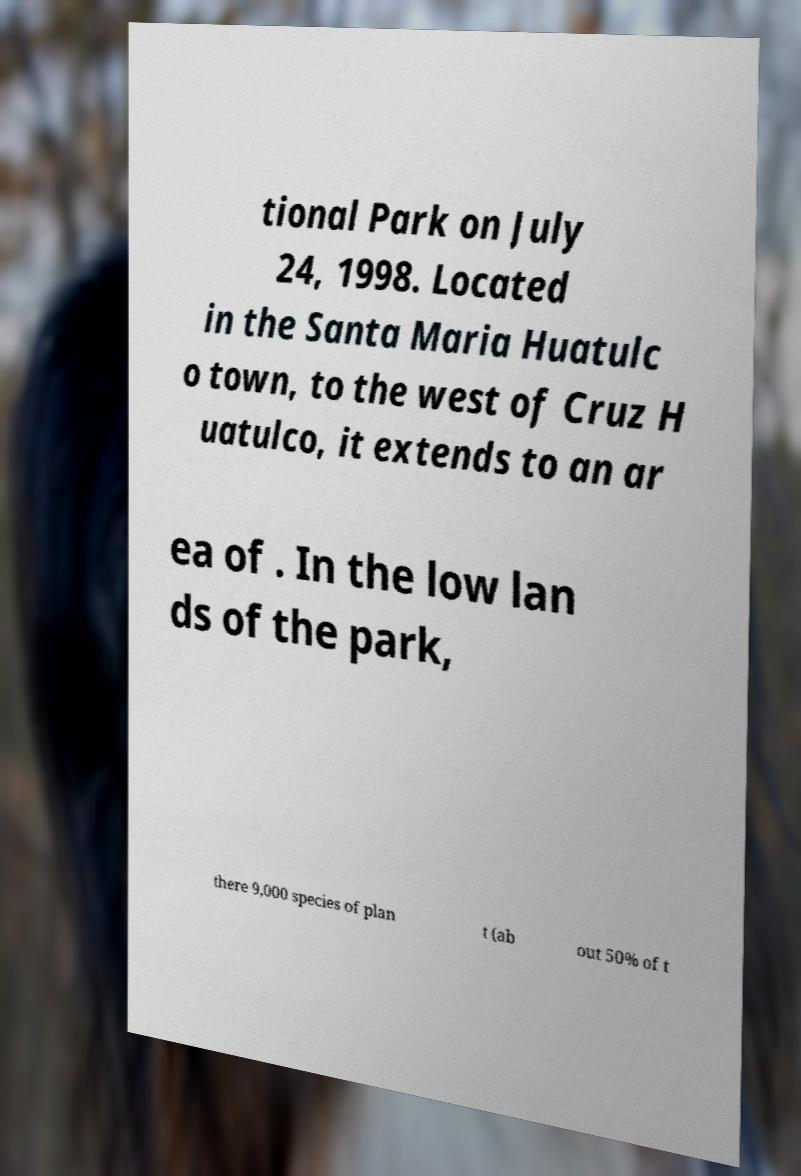Could you extract and type out the text from this image? tional Park on July 24, 1998. Located in the Santa Maria Huatulc o town, to the west of Cruz H uatulco, it extends to an ar ea of . In the low lan ds of the park, there 9,000 species of plan t (ab out 50% of t 